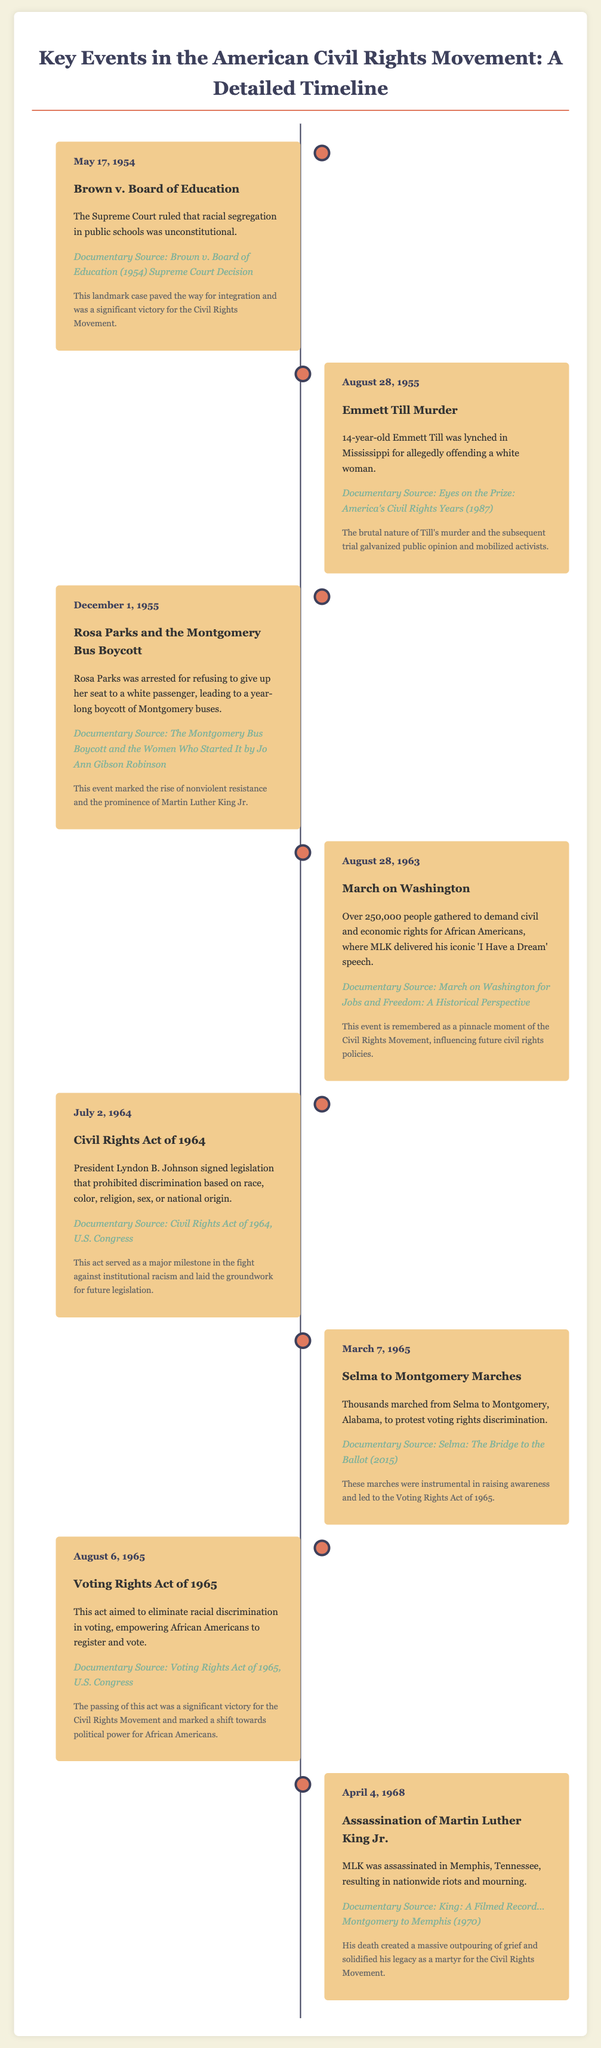What is the date of the Brown v. Board of Education ruling? The date is mentioned in the document under the associated event, which is May 17, 1954.
Answer: May 17, 1954 Who was lynched in Mississippi in 1955? The document states that 14-year-old Emmett Till was the victim of the lynching.
Answer: Emmett Till What legislation was signed on July 2, 1964? The document outlines that the Civil Rights Act of 1964 was signed into law on this date.
Answer: Civil Rights Act of 1964 Which significant speech was delivered during the March on Washington? The document indicates that MLK delivered his iconic 'I Have a Dream' speech.
Answer: 'I Have a Dream' What was the main purpose of the Selma to Montgomery marches? The document notes that the marches were to protest voting rights discrimination.
Answer: Voting rights discrimination What year did the Voting Rights Act take place? The document provides the date of this significant event as August 6, 1965.
Answer: 1965 Which event is associated with the assassination of Martin Luther King Jr.? The document specifies that his assassination occurred on April 4, 1968.
Answer: April 4, 1968 What source is referenced for the Emmett Till murder description? The document includes the source as "Eyes on the Prize: America's Civil Rights Years (1987)."
Answer: Eyes on the Prize: America's Civil Rights Years (1987) How many people gathered for the March on Washington? The document describes that over 250,000 people attended the event.
Answer: Over 250,000 